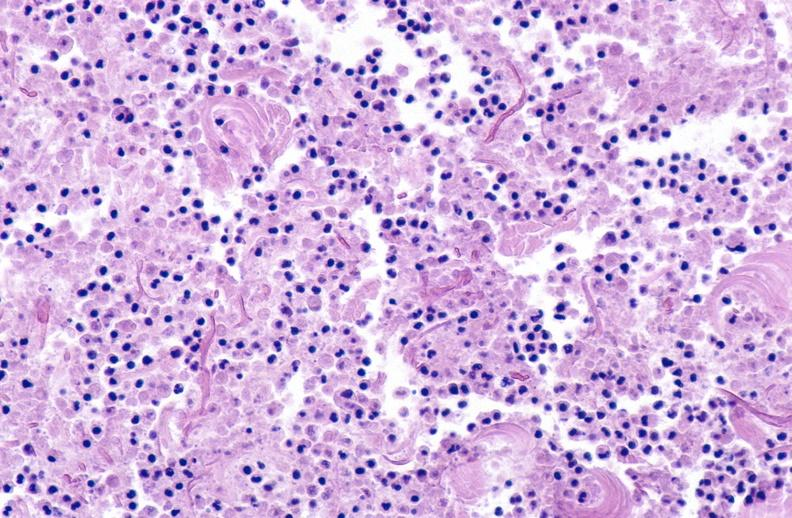does this image show panniculitis and fascitis?
Answer the question using a single word or phrase. Yes 